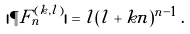<formula> <loc_0><loc_0><loc_500><loc_500>| \P F ^ { ( k , l ) } _ { n } | = l ( l + k n ) ^ { n - 1 } \, .</formula> 